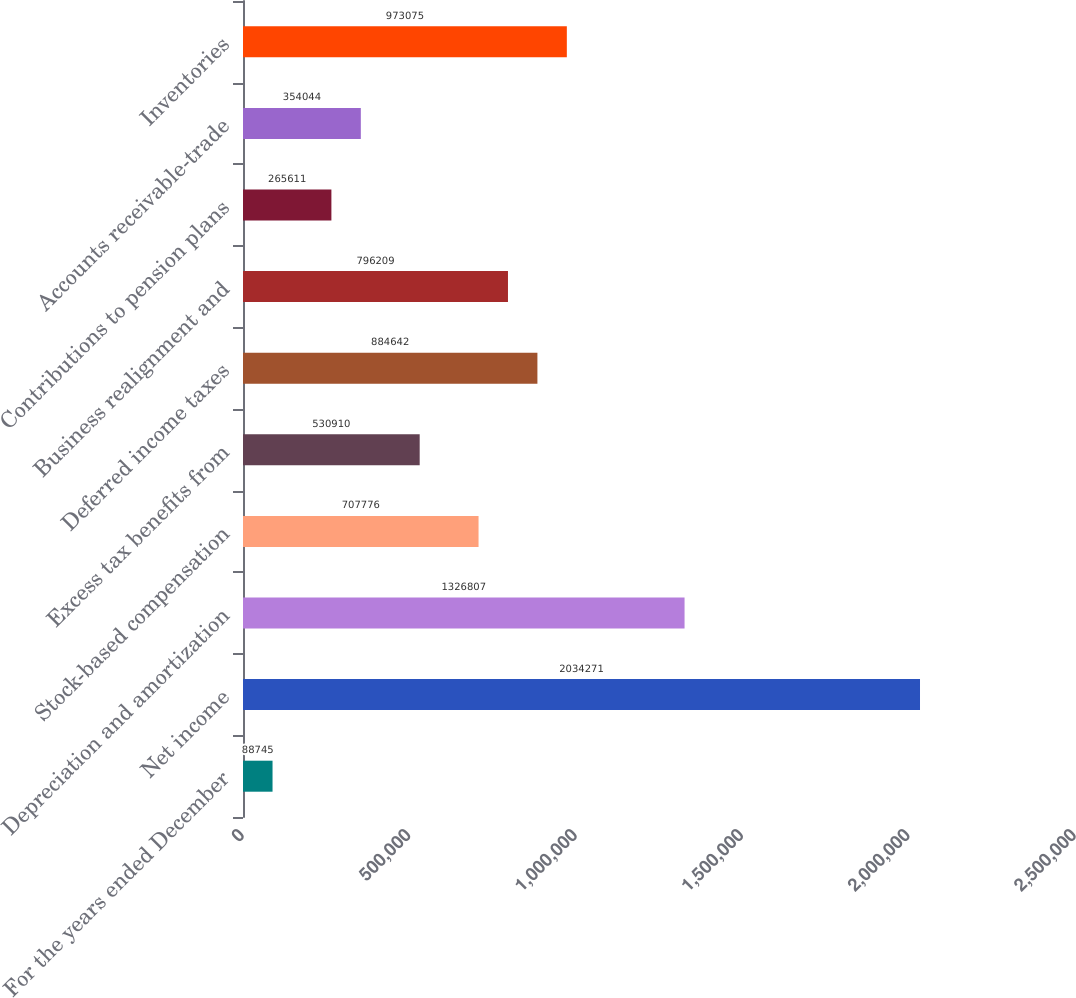Convert chart to OTSL. <chart><loc_0><loc_0><loc_500><loc_500><bar_chart><fcel>For the years ended December<fcel>Net income<fcel>Depreciation and amortization<fcel>Stock-based compensation<fcel>Excess tax benefits from<fcel>Deferred income taxes<fcel>Business realignment and<fcel>Contributions to pension plans<fcel>Accounts receivable-trade<fcel>Inventories<nl><fcel>88745<fcel>2.03427e+06<fcel>1.32681e+06<fcel>707776<fcel>530910<fcel>884642<fcel>796209<fcel>265611<fcel>354044<fcel>973075<nl></chart> 